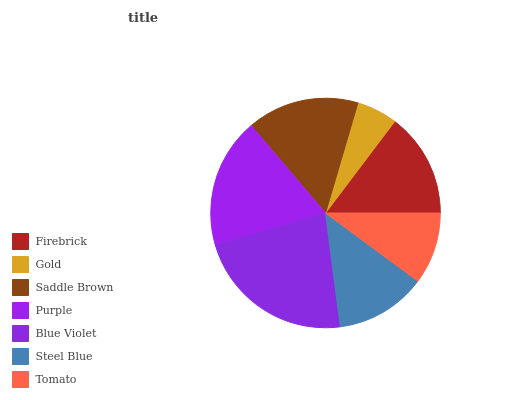Is Gold the minimum?
Answer yes or no. Yes. Is Blue Violet the maximum?
Answer yes or no. Yes. Is Saddle Brown the minimum?
Answer yes or no. No. Is Saddle Brown the maximum?
Answer yes or no. No. Is Saddle Brown greater than Gold?
Answer yes or no. Yes. Is Gold less than Saddle Brown?
Answer yes or no. Yes. Is Gold greater than Saddle Brown?
Answer yes or no. No. Is Saddle Brown less than Gold?
Answer yes or no. No. Is Firebrick the high median?
Answer yes or no. Yes. Is Firebrick the low median?
Answer yes or no. Yes. Is Blue Violet the high median?
Answer yes or no. No. Is Saddle Brown the low median?
Answer yes or no. No. 